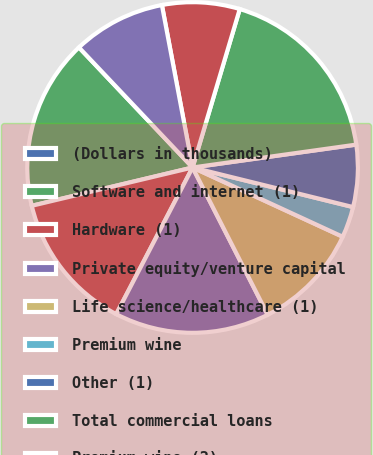<chart> <loc_0><loc_0><loc_500><loc_500><pie_chart><fcel>(Dollars in thousands)<fcel>Software and internet (1)<fcel>Hardware (1)<fcel>Private equity/venture capital<fcel>Life science/healthcare (1)<fcel>Premium wine<fcel>Other (1)<fcel>Total commercial loans<fcel>Premium wine (2)<fcel>Consumer loans (3)<nl><fcel>0.0%<fcel>16.66%<fcel>13.64%<fcel>15.15%<fcel>10.61%<fcel>3.03%<fcel>6.06%<fcel>18.18%<fcel>7.58%<fcel>9.09%<nl></chart> 